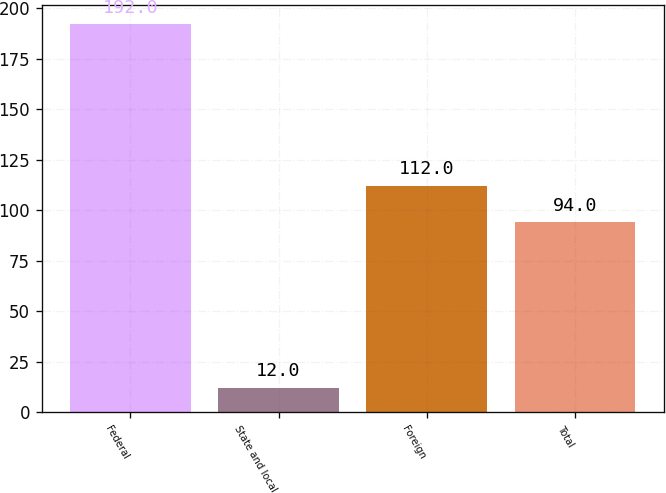Convert chart to OTSL. <chart><loc_0><loc_0><loc_500><loc_500><bar_chart><fcel>Federal<fcel>State and local<fcel>Foreign<fcel>Total<nl><fcel>192<fcel>12<fcel>112<fcel>94<nl></chart> 